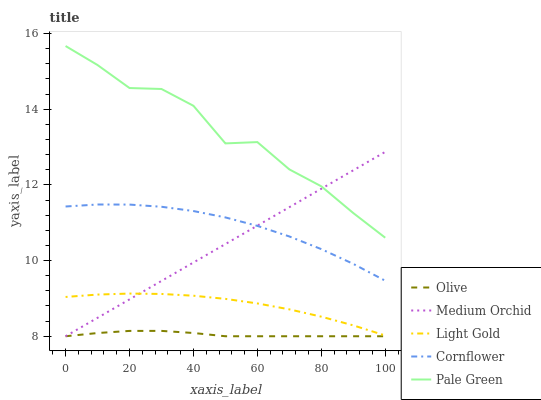Does Cornflower have the minimum area under the curve?
Answer yes or no. No. Does Cornflower have the maximum area under the curve?
Answer yes or no. No. Is Cornflower the smoothest?
Answer yes or no. No. Is Cornflower the roughest?
Answer yes or no. No. Does Cornflower have the lowest value?
Answer yes or no. No. Does Cornflower have the highest value?
Answer yes or no. No. Is Olive less than Light Gold?
Answer yes or no. Yes. Is Light Gold greater than Olive?
Answer yes or no. Yes. Does Olive intersect Light Gold?
Answer yes or no. No. 